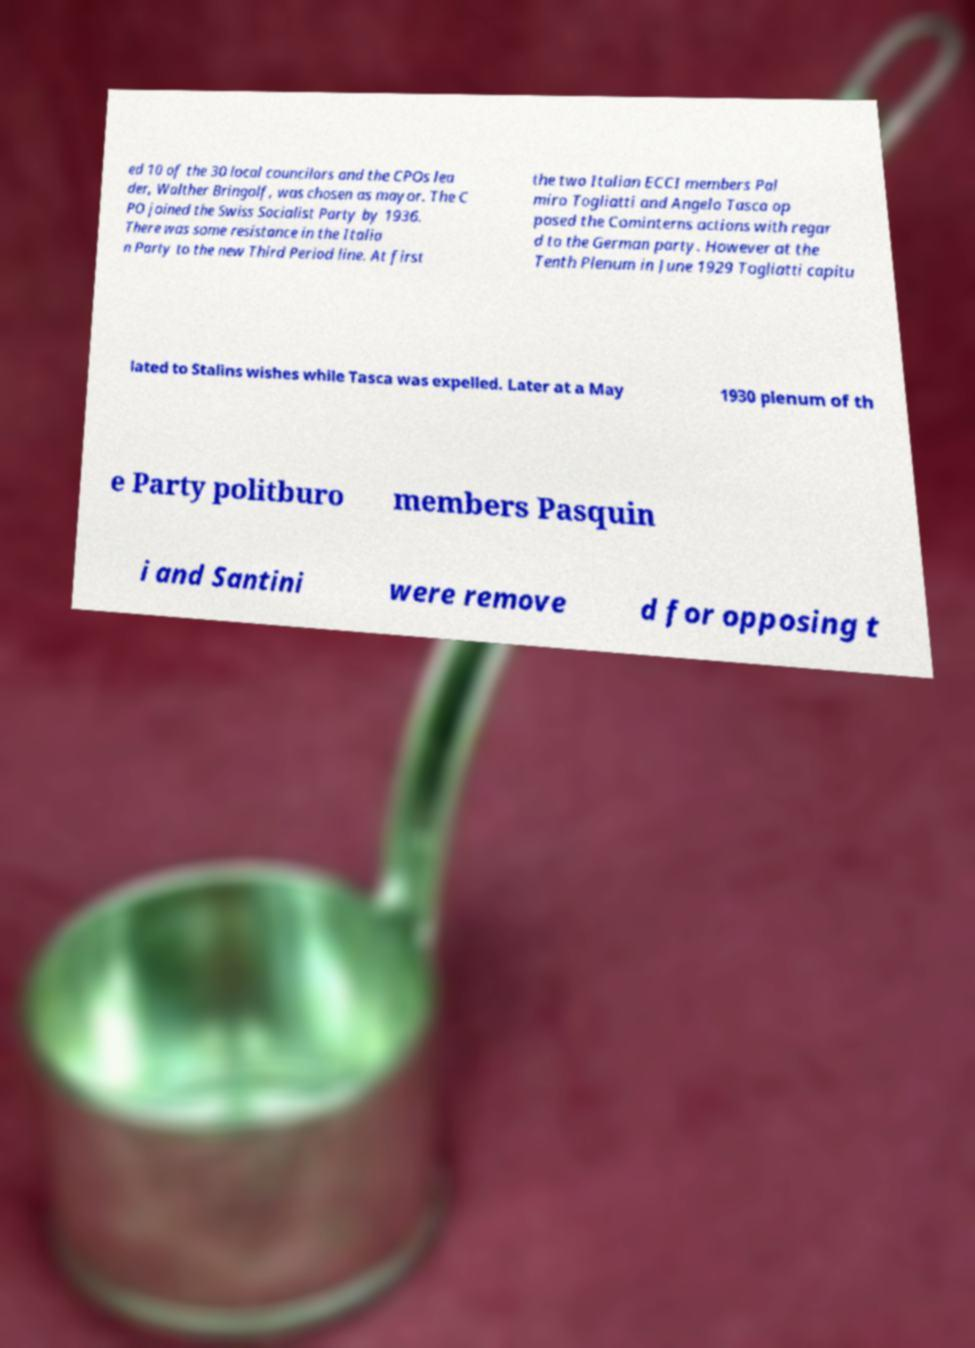What messages or text are displayed in this image? I need them in a readable, typed format. ed 10 of the 30 local councilors and the CPOs lea der, Walther Bringolf, was chosen as mayor. The C PO joined the Swiss Socialist Party by 1936. There was some resistance in the Italia n Party to the new Third Period line. At first the two Italian ECCI members Pal miro Togliatti and Angelo Tasca op posed the Cominterns actions with regar d to the German party. However at the Tenth Plenum in June 1929 Togliatti capitu lated to Stalins wishes while Tasca was expelled. Later at a May 1930 plenum of th e Party politburo members Pasquin i and Santini were remove d for opposing t 